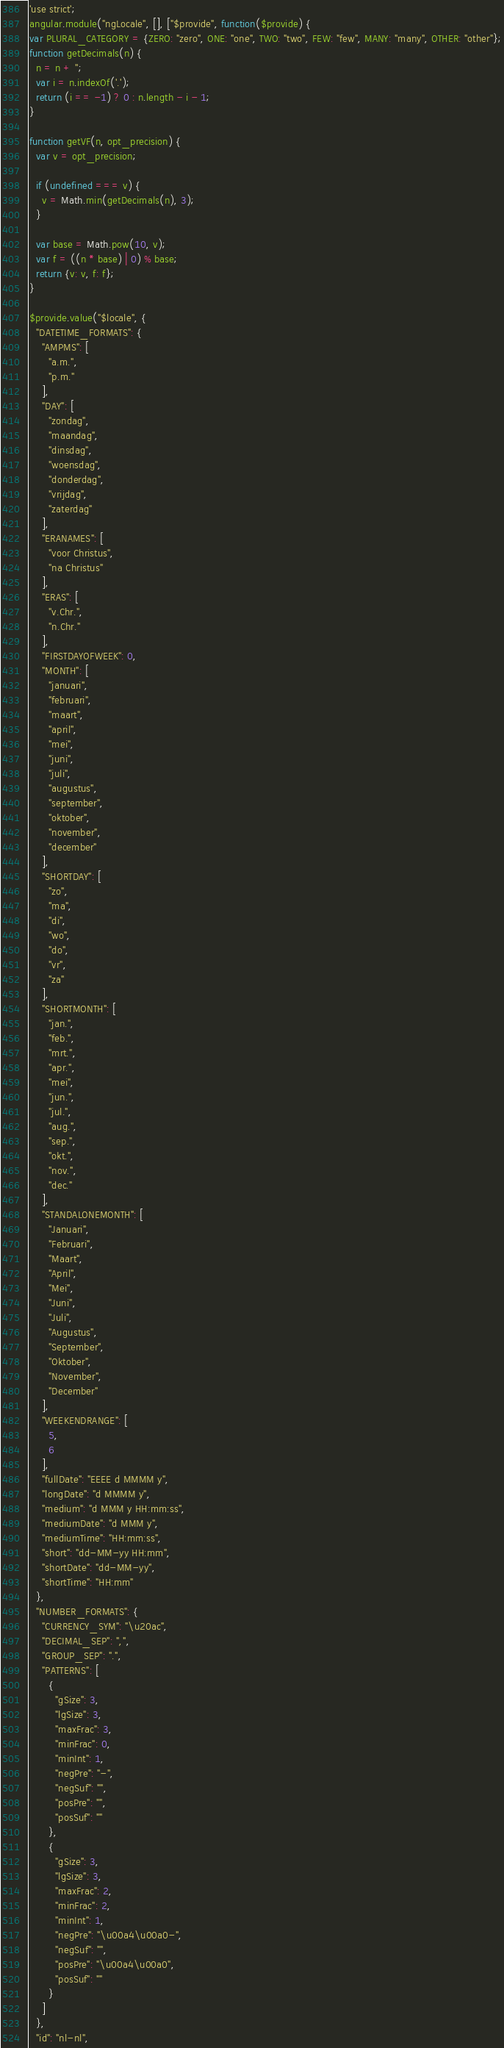Convert code to text. <code><loc_0><loc_0><loc_500><loc_500><_JavaScript_>'use strict';
angular.module("ngLocale", [], ["$provide", function($provide) {
var PLURAL_CATEGORY = {ZERO: "zero", ONE: "one", TWO: "two", FEW: "few", MANY: "many", OTHER: "other"};
function getDecimals(n) {
  n = n + '';
  var i = n.indexOf('.');
  return (i == -1) ? 0 : n.length - i - 1;
}

function getVF(n, opt_precision) {
  var v = opt_precision;

  if (undefined === v) {
    v = Math.min(getDecimals(n), 3);
  }

  var base = Math.pow(10, v);
  var f = ((n * base) | 0) % base;
  return {v: v, f: f};
}

$provide.value("$locale", {
  "DATETIME_FORMATS": {
    "AMPMS": [
      "a.m.",
      "p.m."
    ],
    "DAY": [
      "zondag",
      "maandag",
      "dinsdag",
      "woensdag",
      "donderdag",
      "vrijdag",
      "zaterdag"
    ],
    "ERANAMES": [
      "voor Christus",
      "na Christus"
    ],
    "ERAS": [
      "v.Chr.",
      "n.Chr."
    ],
    "FIRSTDAYOFWEEK": 0,
    "MONTH": [
      "januari",
      "februari",
      "maart",
      "april",
      "mei",
      "juni",
      "juli",
      "augustus",
      "september",
      "oktober",
      "november",
      "december"
    ],
    "SHORTDAY": [
      "zo",
      "ma",
      "di",
      "wo",
      "do",
      "vr",
      "za"
    ],
    "SHORTMONTH": [
      "jan.",
      "feb.",
      "mrt.",
      "apr.",
      "mei",
      "jun.",
      "jul.",
      "aug.",
      "sep.",
      "okt.",
      "nov.",
      "dec."
    ],
    "STANDALONEMONTH": [
      "Januari",
      "Februari",
      "Maart",
      "April",
      "Mei",
      "Juni",
      "Juli",
      "Augustus",
      "September",
      "Oktober",
      "November",
      "December"
    ],
    "WEEKENDRANGE": [
      5,
      6
    ],
    "fullDate": "EEEE d MMMM y",
    "longDate": "d MMMM y",
    "medium": "d MMM y HH:mm:ss",
    "mediumDate": "d MMM y",
    "mediumTime": "HH:mm:ss",
    "short": "dd-MM-yy HH:mm",
    "shortDate": "dd-MM-yy",
    "shortTime": "HH:mm"
  },
  "NUMBER_FORMATS": {
    "CURRENCY_SYM": "\u20ac",
    "DECIMAL_SEP": ",",
    "GROUP_SEP": ".",
    "PATTERNS": [
      {
        "gSize": 3,
        "lgSize": 3,
        "maxFrac": 3,
        "minFrac": 0,
        "minInt": 1,
        "negPre": "-",
        "negSuf": "",
        "posPre": "",
        "posSuf": ""
      },
      {
        "gSize": 3,
        "lgSize": 3,
        "maxFrac": 2,
        "minFrac": 2,
        "minInt": 1,
        "negPre": "\u00a4\u00a0-",
        "negSuf": "",
        "posPre": "\u00a4\u00a0",
        "posSuf": ""
      }
    ]
  },
  "id": "nl-nl",</code> 